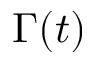Convert formula to latex. <formula><loc_0><loc_0><loc_500><loc_500>\Gamma ( t )</formula> 